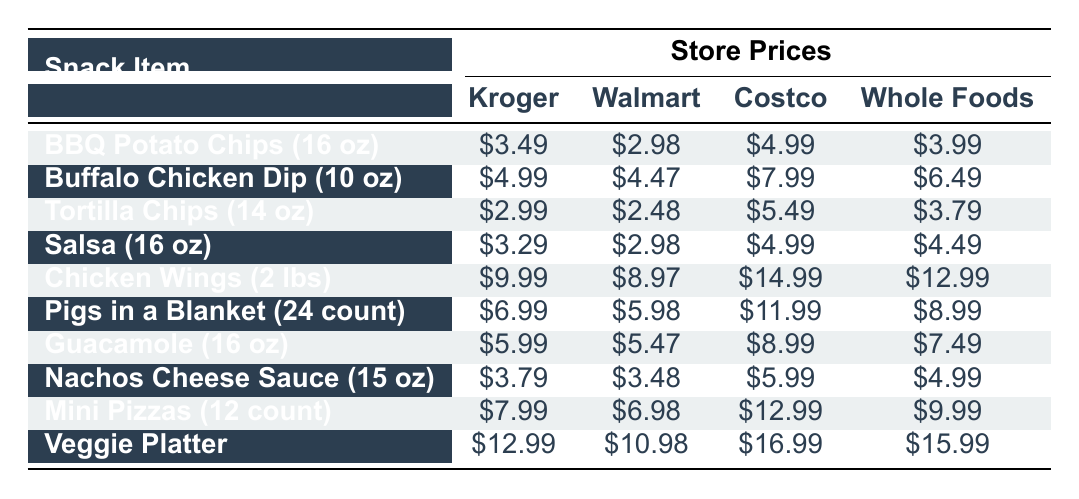What is the price of BBQ Potato Chips at Walmart? According to the table, the price of BBQ Potato Chips at Walmart is listed as $2.98.
Answer: $2.98 Which store has the highest price for Chicken Wings? The prices for Chicken Wings from different stores are: Kroger - $9.99, Walmart - $8.97, Costco - $14.99, and Whole Foods - $12.99. The highest price is $14.99 at Costco.
Answer: $14.99 Are Pigs in a Blanket cheaper at Whole Foods than at Costco? The price of Pigs in a Blanket at Whole Foods is $8.99 and at Costco is $11.99. Since $8.99 is less than $11.99, the statement is true.
Answer: Yes What is the total cost of buying one of each snack from Kroger? To find the total cost from Kroger, add the prices: $3.49 (BBQ Potato Chips) + $4.99 (Buffalo Chicken Dip) + $2.99 (Tortilla Chips) + $3.29 (Salsa) + $9.99 (Chicken Wings) + $6.99 (Pigs in a Blanket) + $5.99 (Guacamole) + $3.79 (Nachos Cheese Sauce) + $7.99 (Mini Pizzas) + $12.99 (Veggie Platter) = $60.40. Therefore, the total cost is $60.40.
Answer: $60.40 What is the average price of Salsa across all stores? The prices of Salsa are: $3.29 (Kroger), $2.98 (Walmart), $4.99 (Costco), and $4.49 (Whole Foods). The sum of these prices is $3.29 + $2.98 + $4.99 + $4.49 = $15.75. To find the average, divide $15.75 by 4 stores, which equals approximately $3.94.
Answer: $3.94 Is Guacamole more expensive at Walmart than at Kroger? The price of Guacamole is $5.47 at Walmart and $5.99 at Kroger. Since $5.47 is less than $5.99, the statement is false.
Answer: No Which item has the largest price difference between Kroger and Walmart? Comparing the differences: BBQ Potato Chips ($3.49 - $2.98 = $0.51), Buffalo Chicken Dip ($4.99 - $4.47 = $0.52), Tortilla Chips ($2.99 - $2.48 = $0.51), Salsa ($3.29 - $2.98 = $0.31), Chicken Wings ($9.99 - $8.97 = $1.02), Pigs in a Blanket ($6.99 - $5.98 = $1.01), Guacamole ($5.99 - $5.47 = $0.52), Nachos Cheese Sauce ($3.79 - $3.48 = $0.31), Mini Pizzas ($7.99 - $6.98 = $1.01), Veggie Platter ($12.99 - $10.98 = $2.01). The largest difference is $2.01 for Veggie Platter.
Answer: $2.01 